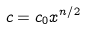Convert formula to latex. <formula><loc_0><loc_0><loc_500><loc_500>c = c _ { 0 } x ^ { n / 2 }</formula> 